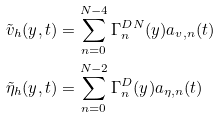<formula> <loc_0><loc_0><loc_500><loc_500>\tilde { v } _ { h } ( y , t ) & = \sum _ { n = 0 } ^ { N - 4 } \Gamma _ { n } ^ { D N } ( y ) a _ { v , n } ( t ) \\ \tilde { \eta } _ { h } ( y , t ) & = \sum _ { n = 0 } ^ { N - 2 } \Gamma _ { n } ^ { D } ( y ) a _ { \eta , n } ( t )</formula> 